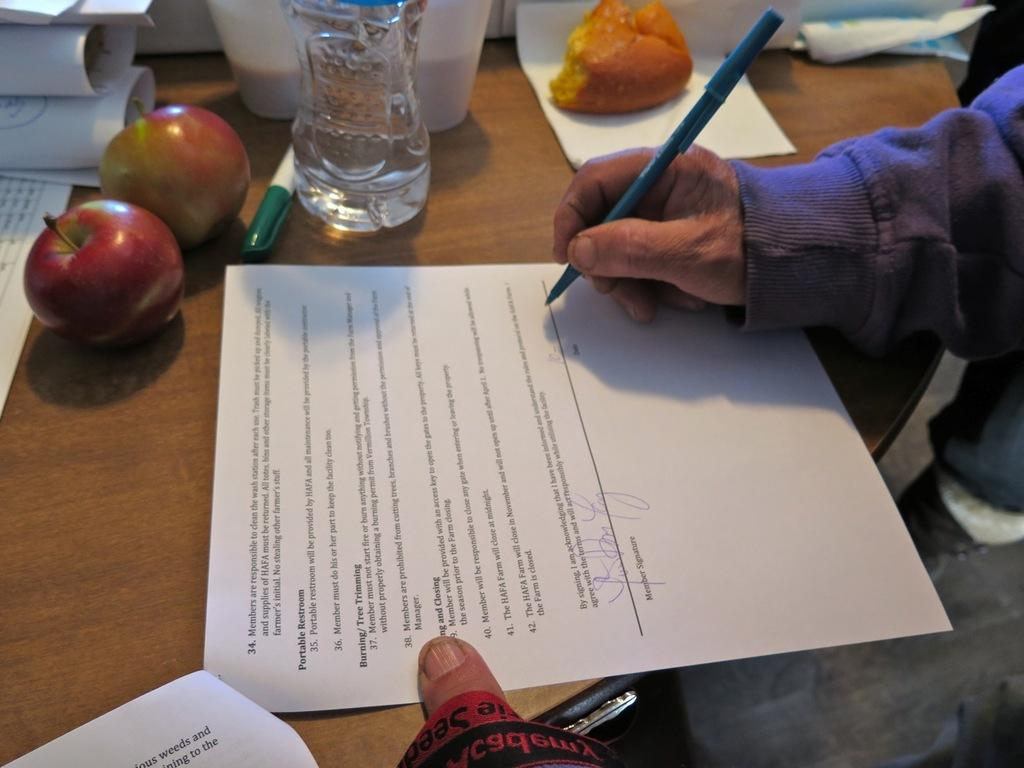What objects are present on the table in the image? There are food items, papers, and a pen on the table. What is the person doing in the image? The person is signing on a paper. What might be used for writing on the papers? A pen is present on the table for writing. What type of pain is the person experiencing while signing the paper in the image? There is no indication in the image that the person is experiencing any pain while signing the paper. What part of the person's body is connected to the pen while signing the paper in the image? The image does not show any specific body part connected to the pen while signing the paper. 